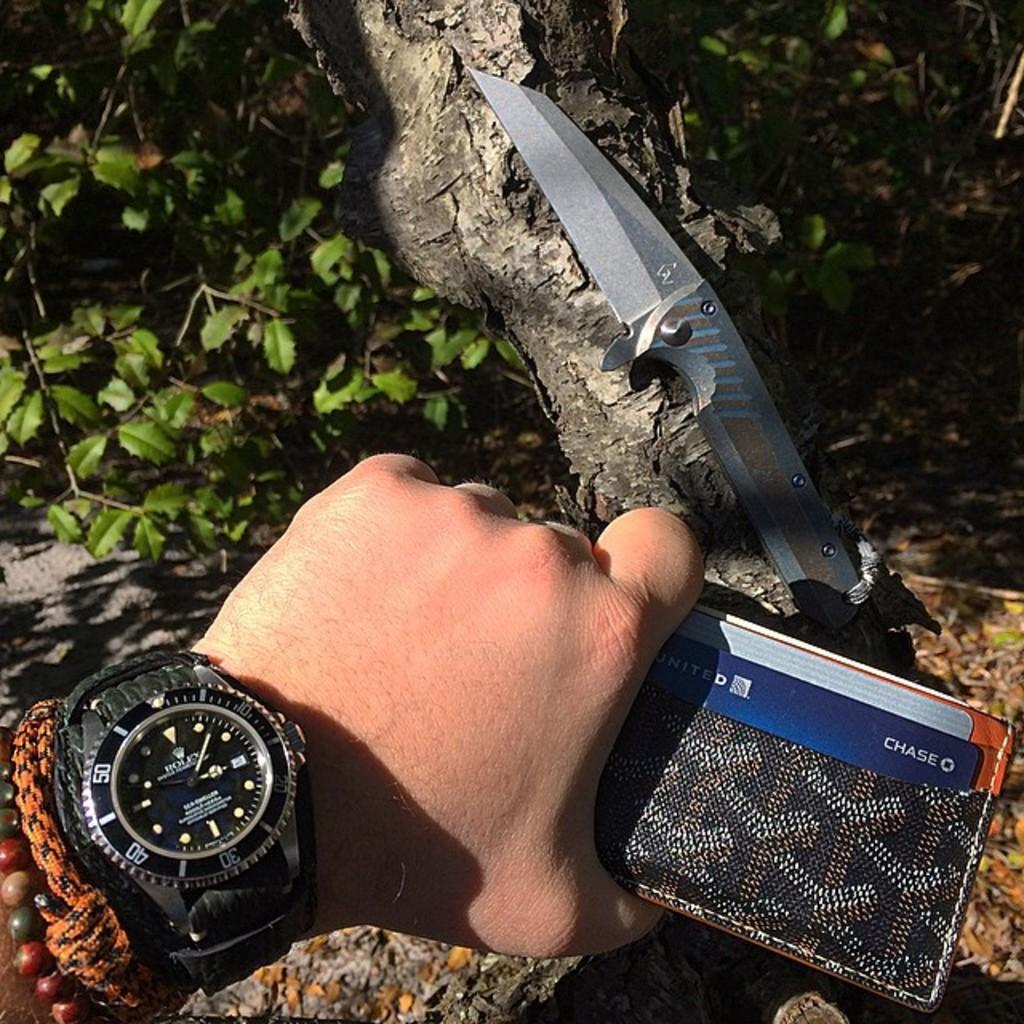<image>
Render a clear and concise summary of the photo. A hand is wearing a watch and holding a Chase card above a knife outside. 